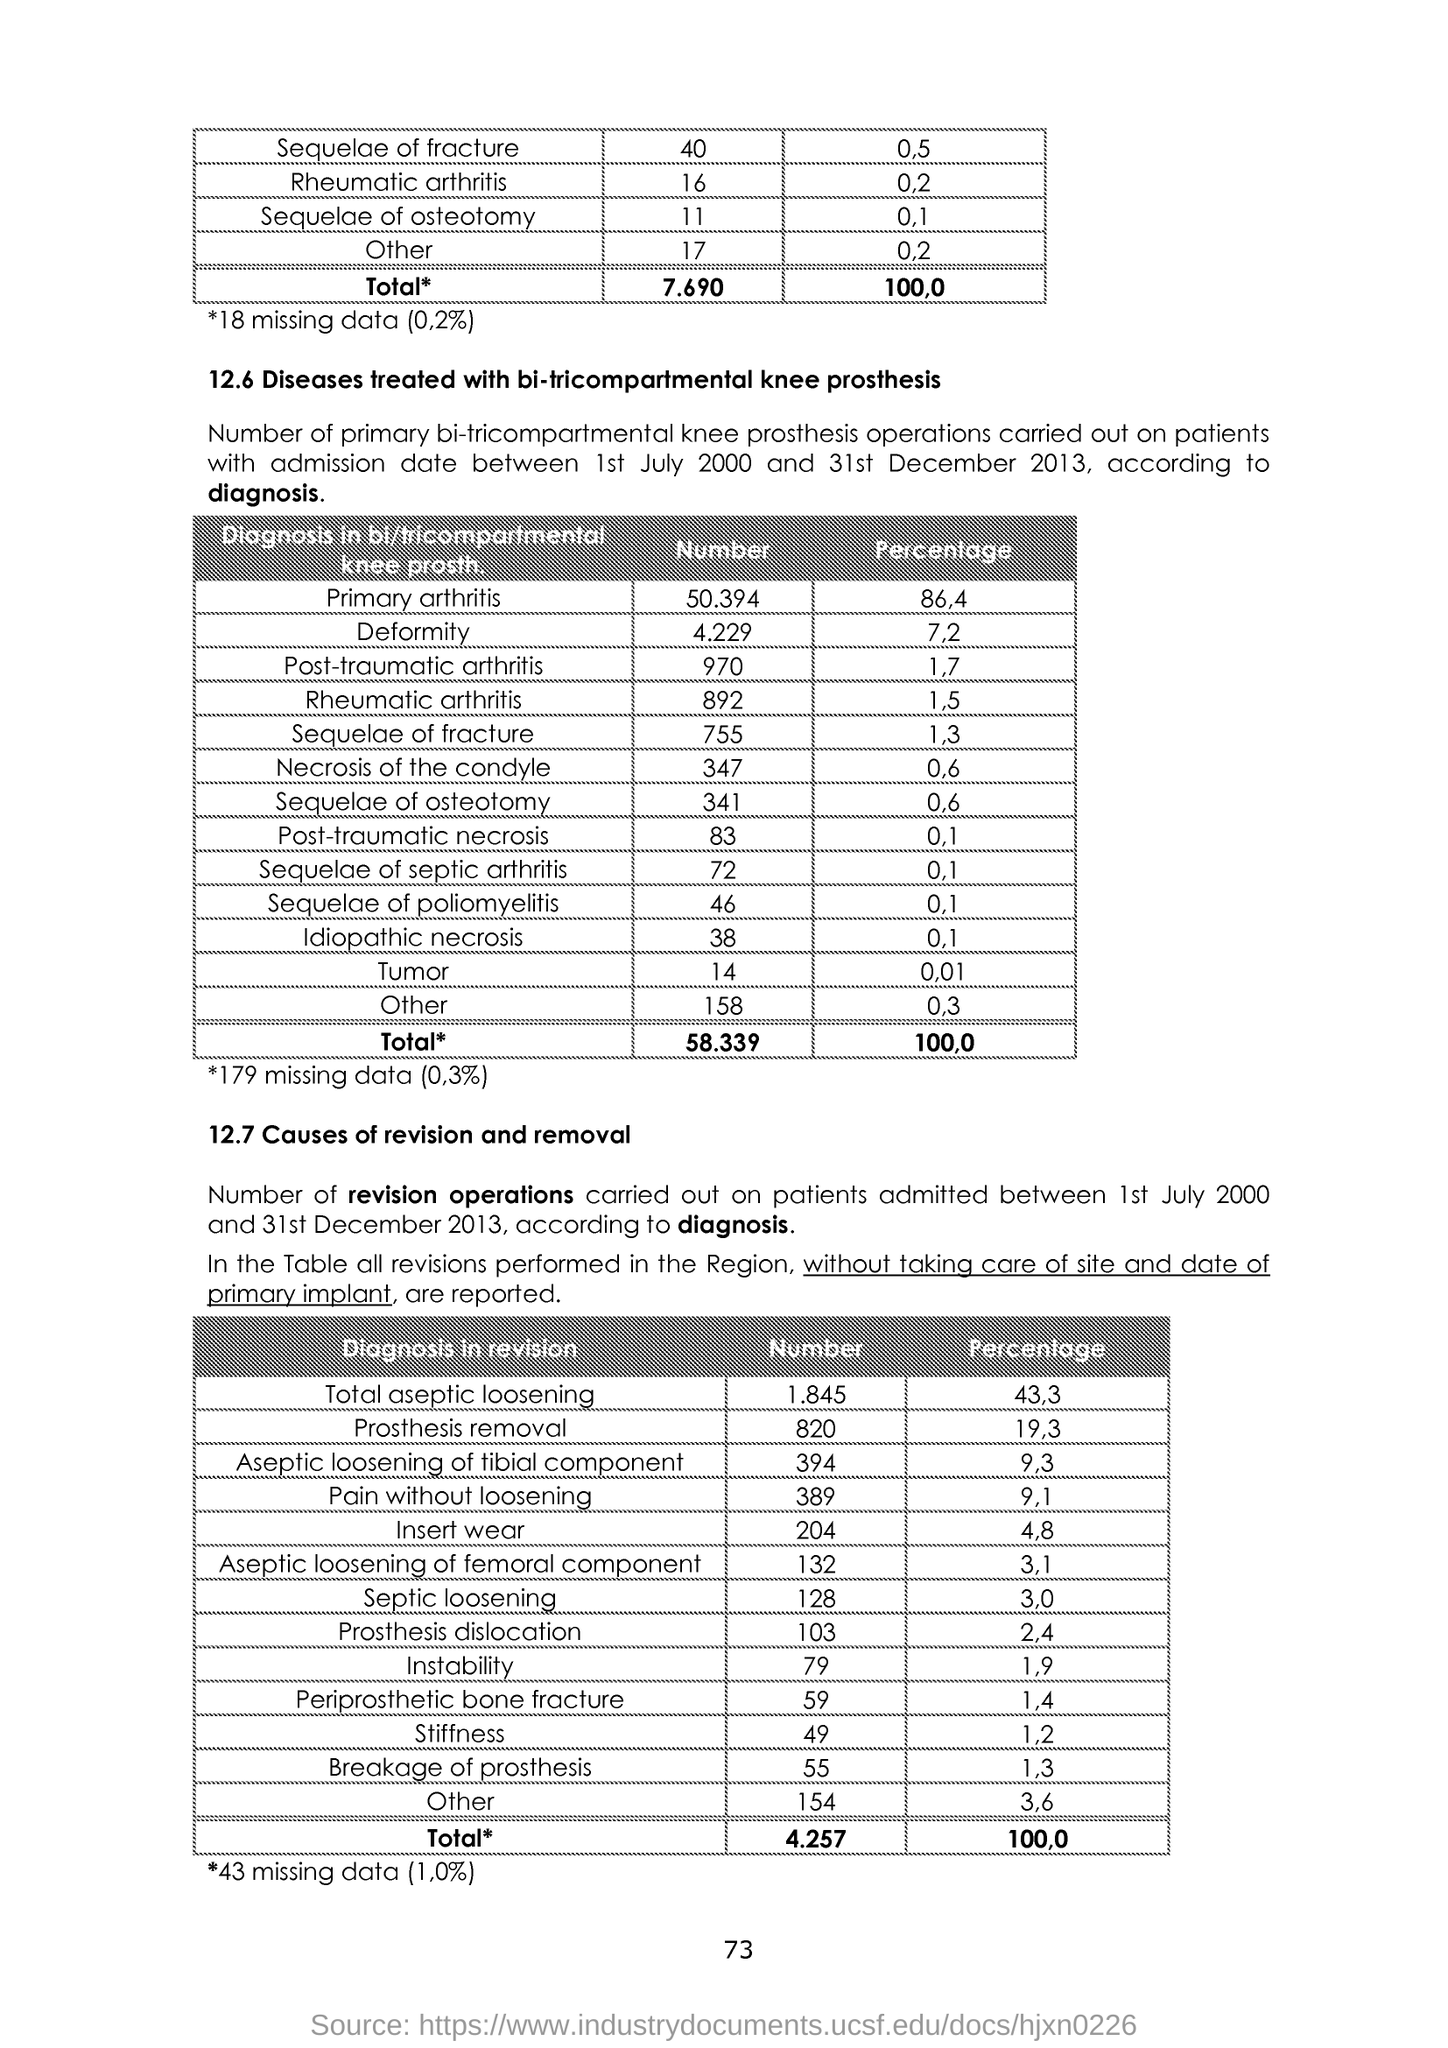What is the number of Prosthesis removal?
Make the answer very short. 820. What is the percentage of Prosthesis dislocation?
Ensure brevity in your answer.  2.4. 